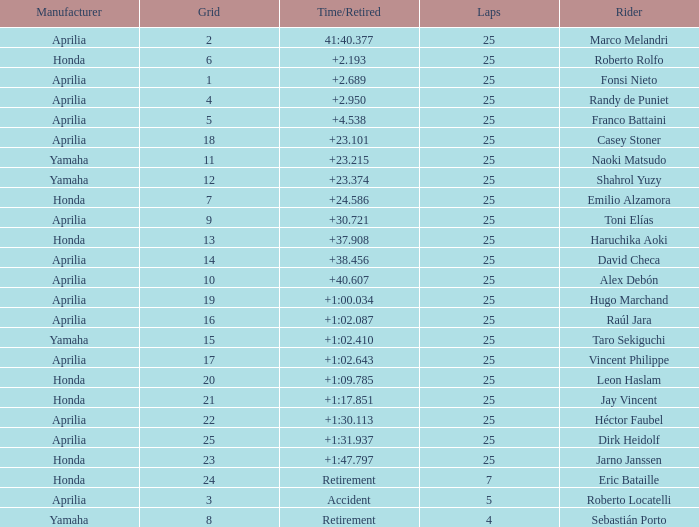Which Manufacturer has a Time/Retired of accident? Aprilia. 